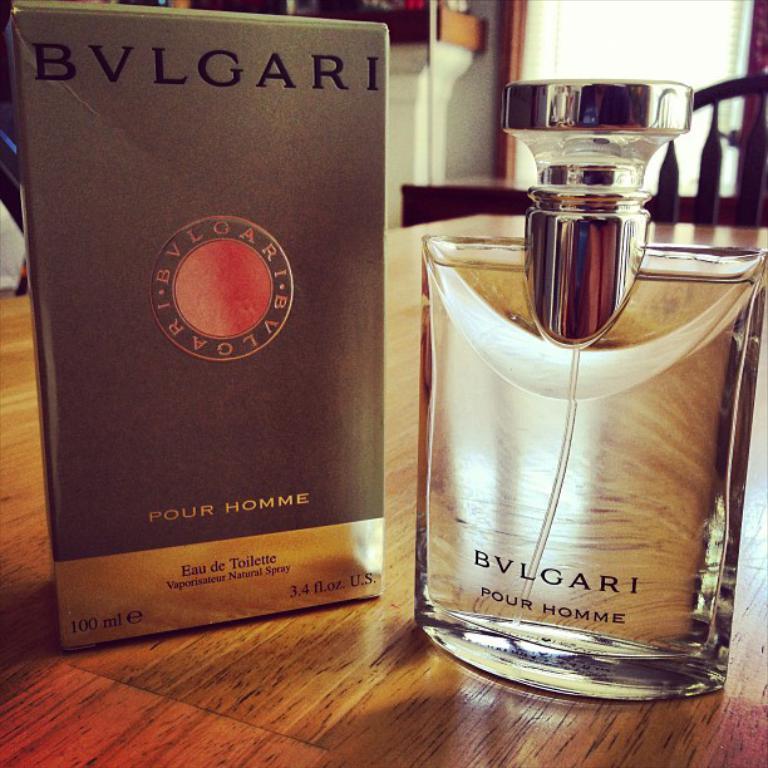What is the name of this purfume?
Offer a terse response. Bvlgari. 